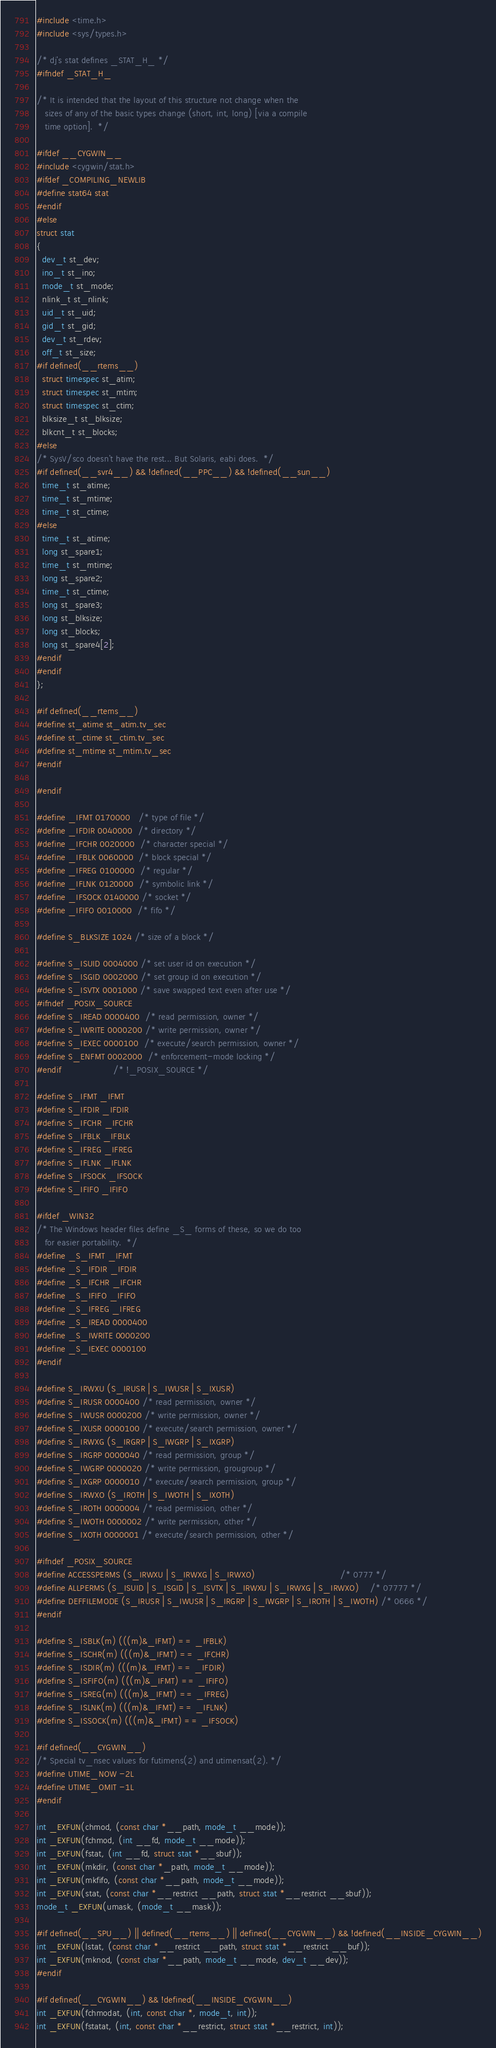Convert code to text. <code><loc_0><loc_0><loc_500><loc_500><_C_>#include <time.h>
#include <sys/types.h>

/* dj's stat defines _STAT_H_ */
#ifndef _STAT_H_

/* It is intended that the layout of this structure not change when the
   sizes of any of the basic types change (short, int, long) [via a compile
   time option].  */

#ifdef __CYGWIN__
#include <cygwin/stat.h>
#ifdef _COMPILING_NEWLIB
#define stat64 stat
#endif
#else
struct stat
{
  dev_t st_dev;
  ino_t st_ino;
  mode_t st_mode;
  nlink_t st_nlink;
  uid_t st_uid;
  gid_t st_gid;
  dev_t st_rdev;
  off_t st_size;
#if defined(__rtems__)
  struct timespec st_atim;
  struct timespec st_mtim;
  struct timespec st_ctim;
  blksize_t st_blksize;
  blkcnt_t st_blocks;
#else
/* SysV/sco doesn't have the rest... But Solaris, eabi does.  */
#if defined(__svr4__) && !defined(__PPC__) && !defined(__sun__)
  time_t st_atime;
  time_t st_mtime;
  time_t st_ctime;
#else
  time_t st_atime;
  long st_spare1;
  time_t st_mtime;
  long st_spare2;
  time_t st_ctime;
  long st_spare3;
  long st_blksize;
  long st_blocks;
  long st_spare4[2];
#endif
#endif
};

#if defined(__rtems__)
#define st_atime st_atim.tv_sec
#define st_ctime st_ctim.tv_sec
#define st_mtime st_mtim.tv_sec
#endif

#endif

#define _IFMT 0170000   /* type of file */
#define _IFDIR 0040000  /* directory */
#define _IFCHR 0020000  /* character special */
#define _IFBLK 0060000  /* block special */
#define _IFREG 0100000  /* regular */
#define _IFLNK 0120000  /* symbolic link */
#define _IFSOCK 0140000 /* socket */
#define _IFIFO 0010000  /* fifo */

#define S_BLKSIZE 1024 /* size of a block */

#define S_ISUID 0004000 /* set user id on execution */
#define S_ISGID 0002000 /* set group id on execution */
#define S_ISVTX 0001000 /* save swapped text even after use */
#ifndef _POSIX_SOURCE
#define S_IREAD 0000400  /* read permission, owner */
#define S_IWRITE 0000200 /* write permission, owner */
#define S_IEXEC 0000100  /* execute/search permission, owner */
#define S_ENFMT 0002000  /* enforcement-mode locking */
#endif                   /* !_POSIX_SOURCE */

#define S_IFMT _IFMT
#define S_IFDIR _IFDIR
#define S_IFCHR _IFCHR
#define S_IFBLK _IFBLK
#define S_IFREG _IFREG
#define S_IFLNK _IFLNK
#define S_IFSOCK _IFSOCK
#define S_IFIFO _IFIFO

#ifdef _WIN32
/* The Windows header files define _S_ forms of these, so we do too
   for easier portability.  */
#define _S_IFMT _IFMT
#define _S_IFDIR _IFDIR
#define _S_IFCHR _IFCHR
#define _S_IFIFO _IFIFO
#define _S_IFREG _IFREG
#define _S_IREAD 0000400
#define _S_IWRITE 0000200
#define _S_IEXEC 0000100
#endif

#define S_IRWXU (S_IRUSR | S_IWUSR | S_IXUSR)
#define S_IRUSR 0000400 /* read permission, owner */
#define S_IWUSR 0000200 /* write permission, owner */
#define S_IXUSR 0000100 /* execute/search permission, owner */
#define S_IRWXG (S_IRGRP | S_IWGRP | S_IXGRP)
#define S_IRGRP 0000040 /* read permission, group */
#define S_IWGRP 0000020 /* write permission, grougroup */
#define S_IXGRP 0000010 /* execute/search permission, group */
#define S_IRWXO (S_IROTH | S_IWOTH | S_IXOTH)
#define S_IROTH 0000004 /* read permission, other */
#define S_IWOTH 0000002 /* write permission, other */
#define S_IXOTH 0000001 /* execute/search permission, other */

#ifndef _POSIX_SOURCE
#define ACCESSPERMS (S_IRWXU | S_IRWXG | S_IRWXO)                               /* 0777 */
#define ALLPERMS (S_ISUID | S_ISGID | S_ISVTX | S_IRWXU | S_IRWXG | S_IRWXO)    /* 07777 */
#define DEFFILEMODE (S_IRUSR | S_IWUSR | S_IRGRP | S_IWGRP | S_IROTH | S_IWOTH) /* 0666 */
#endif

#define S_ISBLK(m) (((m)&_IFMT) == _IFBLK)
#define S_ISCHR(m) (((m)&_IFMT) == _IFCHR)
#define S_ISDIR(m) (((m)&_IFMT) == _IFDIR)
#define S_ISFIFO(m) (((m)&_IFMT) == _IFIFO)
#define S_ISREG(m) (((m)&_IFMT) == _IFREG)
#define S_ISLNK(m) (((m)&_IFMT) == _IFLNK)
#define S_ISSOCK(m) (((m)&_IFMT) == _IFSOCK)

#if defined(__CYGWIN__)
/* Special tv_nsec values for futimens(2) and utimensat(2). */
#define UTIME_NOW -2L
#define UTIME_OMIT -1L
#endif

int _EXFUN(chmod, (const char *__path, mode_t __mode));
int _EXFUN(fchmod, (int __fd, mode_t __mode));
int _EXFUN(fstat, (int __fd, struct stat *__sbuf));
int _EXFUN(mkdir, (const char *_path, mode_t __mode));
int _EXFUN(mkfifo, (const char *__path, mode_t __mode));
int _EXFUN(stat, (const char *__restrict __path, struct stat *__restrict __sbuf));
mode_t _EXFUN(umask, (mode_t __mask));

#if defined(__SPU__) || defined(__rtems__) || defined(__CYGWIN__) && !defined(__INSIDE_CYGWIN__)
int _EXFUN(lstat, (const char *__restrict __path, struct stat *__restrict __buf));
int _EXFUN(mknod, (const char *__path, mode_t __mode, dev_t __dev));
#endif

#if defined(__CYGWIN__) && !defined(__INSIDE_CYGWIN__)
int _EXFUN(fchmodat, (int, const char *, mode_t, int));
int _EXFUN(fstatat, (int, const char *__restrict, struct stat *__restrict, int));</code> 